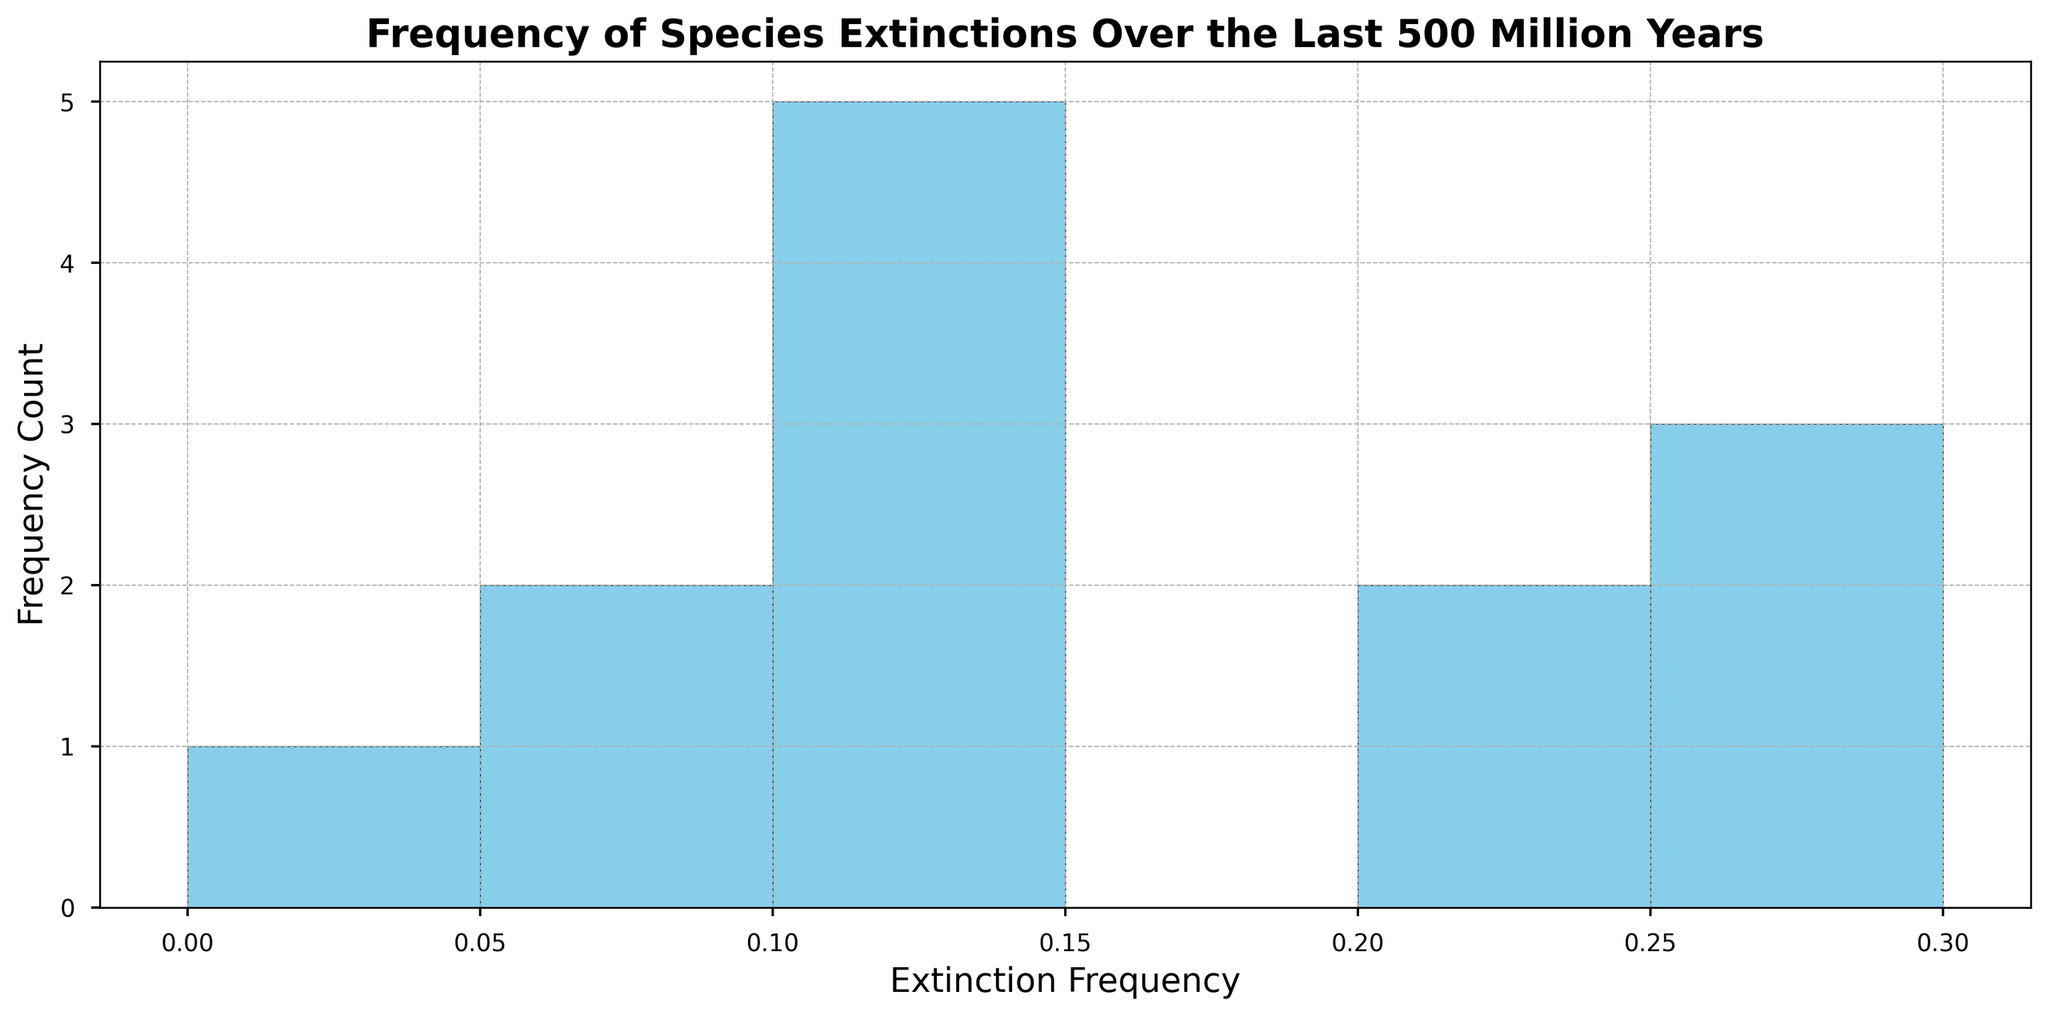What's the most common extinction frequency range? By observing the histogram, identify the bar with the highest count of occurrences and determine the extinction frequency range it represents.
Answer: 0.05 - 0.1 Which extinction frequency range has the least occurrences? Determine the bar with the lowest height in the histogram and note the extinction frequency range it covers.
Answer: 0.25 - 0.3 What is the median extinction frequency? Order the extinction frequencies from least to greatest (0.02, 0.05, 0.05, 0.1, 0.1, 0.15, 0.15, 0.2, 0.2, 0.25, 0.25, 0.3). The middle values are 0.15 and 0.15, so the median is 0.15.
Answer: 0.15 How many frequency ranges are there between 0.1 and 0.2? Locate the bins corresponding to the frequencies between 0.1 and 0.2 on the histogram and count them.
Answer: 2 Are extinction frequencies more commonly less than 0.2 or greater than 0.2? Compare the heights of the bars representing frequencies less than 0.2 with those representing frequencies greater than 0.2.
Answer: Less than 0.2 What is the highest extinction frequency range that appeared more than once? Identify all frequency ranges appearing more than once and find the one with the highest value.
Answer: 0.25 Which period had an extinction frequency in the range of 0.3? Match the extinction frequency of 0.3 to the corresponding period listed in the dataset.
Answer: Permian How many periods had an extinction frequency of 0.25? Check the number of periods associated with an extinction frequency of 0.25 in the dataset.
Answer: 2 